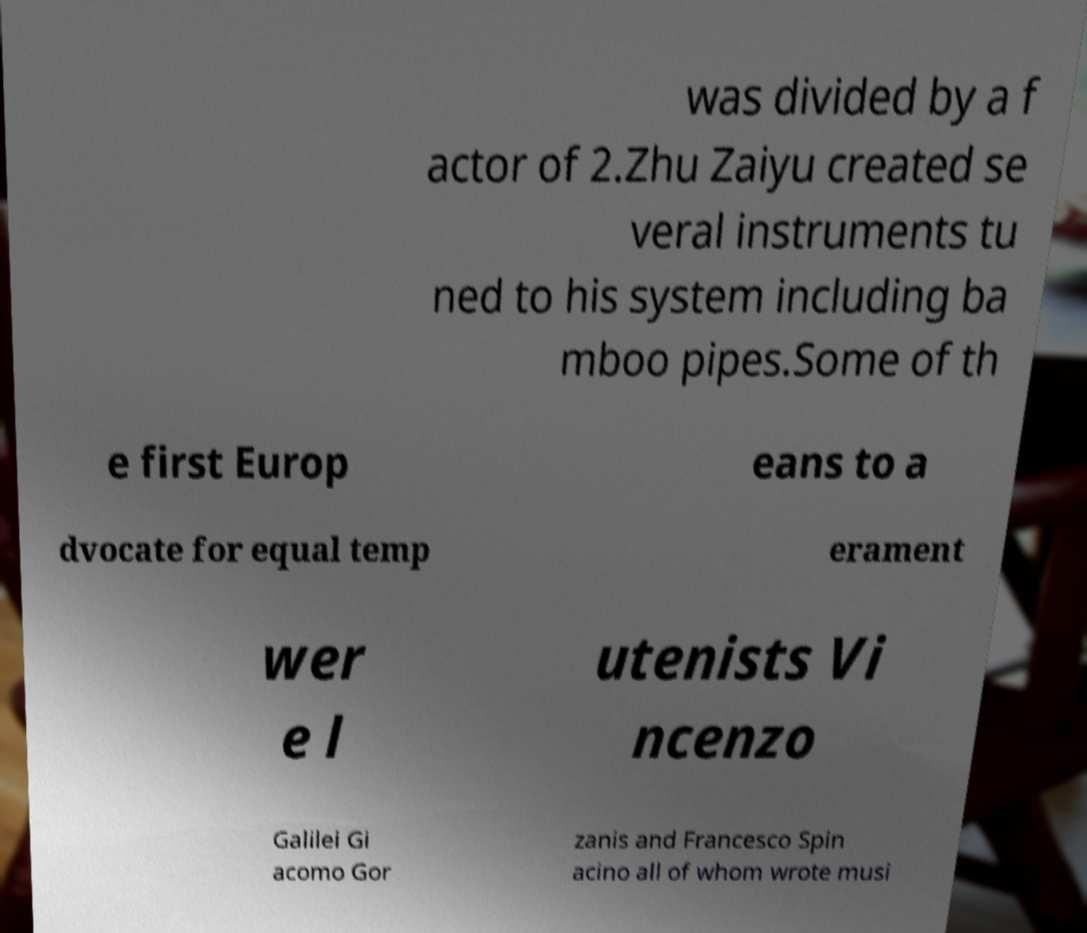What messages or text are displayed in this image? I need them in a readable, typed format. was divided by a f actor of 2.Zhu Zaiyu created se veral instruments tu ned to his system including ba mboo pipes.Some of th e first Europ eans to a dvocate for equal temp erament wer e l utenists Vi ncenzo Galilei Gi acomo Gor zanis and Francesco Spin acino all of whom wrote musi 